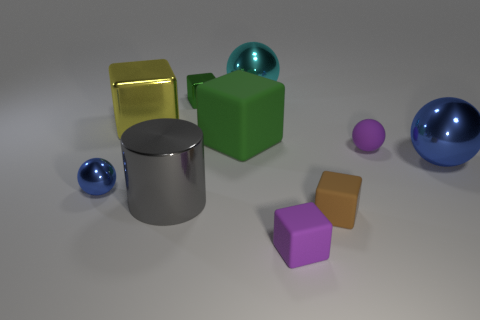What is the shape of the blue shiny object that is on the right side of the big ball left of the big shiny sphere that is on the right side of the large cyan metallic ball?
Offer a terse response. Sphere. How many things are either green metal objects or large purple rubber cylinders?
Offer a terse response. 1. There is a small metal object behind the small blue metal thing; is its shape the same as the tiny purple thing that is in front of the tiny metal sphere?
Offer a terse response. Yes. How many small cubes are both right of the large cyan shiny thing and behind the tiny purple matte block?
Offer a terse response. 1. What number of other things are there of the same size as the green rubber object?
Give a very brief answer. 4. There is a sphere that is behind the large blue ball and in front of the big cyan shiny ball; what is its material?
Offer a terse response. Rubber. There is a rubber sphere; does it have the same color as the tiny rubber cube to the left of the brown thing?
Make the answer very short. Yes. There is a purple thing that is the same shape as the big yellow object; what size is it?
Make the answer very short. Small. What shape is the big metal object that is both on the right side of the big gray shiny cylinder and behind the purple rubber ball?
Keep it short and to the point. Sphere. Does the yellow cube have the same size as the blue sphere on the right side of the green matte thing?
Provide a short and direct response. Yes. 